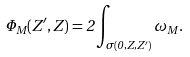Convert formula to latex. <formula><loc_0><loc_0><loc_500><loc_500>\Phi _ { M } ( Z ^ { \prime } , Z ) = 2 \int _ { \sigma ( 0 , Z , Z ^ { \prime } ) } \omega _ { M } .</formula> 